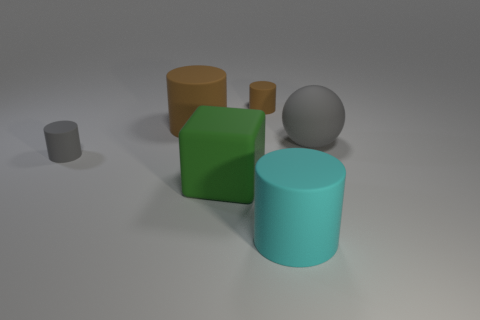Are there more rubber things on the left side of the big green object than yellow matte blocks? Upon examining the image, it appears that there are two objects on the left side of the large green cylinder. One of these is another cylinder that has a rubber-like texture, and the other is a cube with what may be interpreted as a matte surface. Comparing these objects with the yellow block on the right, it is accurate to say that there is only one rubber object on the left side of the green cylinder. Therefore, there are not more rubber things than yellow matte blocks; both qualities are represented by a single item, respectively. 